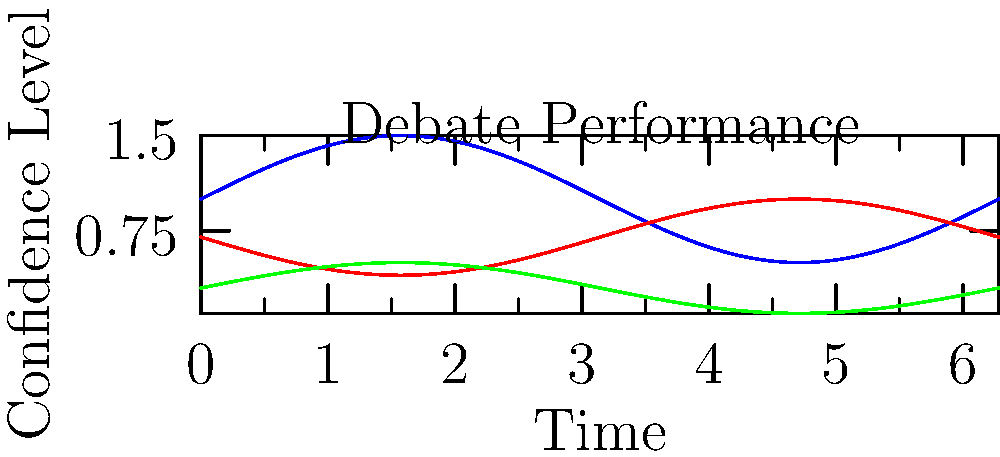In this political debate performance chart, which candidate exhibits the most consistent confidence level throughout the debate, potentially indicating better control over their body language? To determine which candidate shows the most consistent confidence level, we need to analyze the amplitude and frequency of the oscillations in each candidate's graph:

1. Candidate A (blue line):
   - Has the highest amplitude, ranging from approximately 0.5 to 1.5
   - Shows significant fluctuations in confidence

2. Candidate B (red line):
   - Has a moderate amplitude, ranging from about 0.4 to 1.0
   - Shows noticeable fluctuations, but less than Candidate A

3. Candidate C (green line):
   - Has the lowest amplitude, ranging from approximately 0.1 to 0.5
   - Shows the least fluctuation among all candidates

The candidate with the most consistent confidence level will have the smallest amplitude in their graph, indicating less variation in their body language and perceived confidence throughout the debate.

Based on this analysis, Candidate C (green line) demonstrates the most consistent confidence level, as their graph has the smallest amplitude and the least fluctuation over time.
Answer: Candidate C 